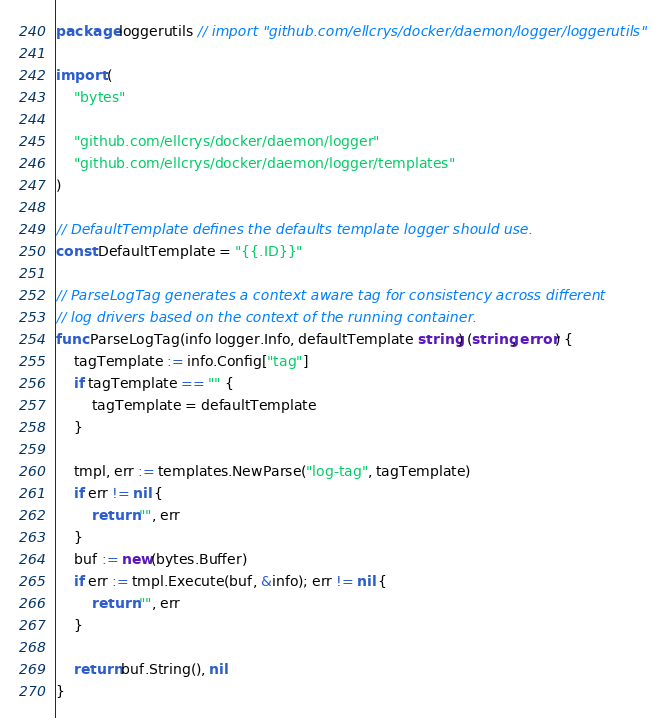Convert code to text. <code><loc_0><loc_0><loc_500><loc_500><_Go_>package loggerutils // import "github.com/ellcrys/docker/daemon/logger/loggerutils"

import (
	"bytes"

	"github.com/ellcrys/docker/daemon/logger"
	"github.com/ellcrys/docker/daemon/logger/templates"
)

// DefaultTemplate defines the defaults template logger should use.
const DefaultTemplate = "{{.ID}}"

// ParseLogTag generates a context aware tag for consistency across different
// log drivers based on the context of the running container.
func ParseLogTag(info logger.Info, defaultTemplate string) (string, error) {
	tagTemplate := info.Config["tag"]
	if tagTemplate == "" {
		tagTemplate = defaultTemplate
	}

	tmpl, err := templates.NewParse("log-tag", tagTemplate)
	if err != nil {
		return "", err
	}
	buf := new(bytes.Buffer)
	if err := tmpl.Execute(buf, &info); err != nil {
		return "", err
	}

	return buf.String(), nil
}
</code> 